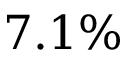Convert formula to latex. <formula><loc_0><loc_0><loc_500><loc_500>7 . 1 \%</formula> 